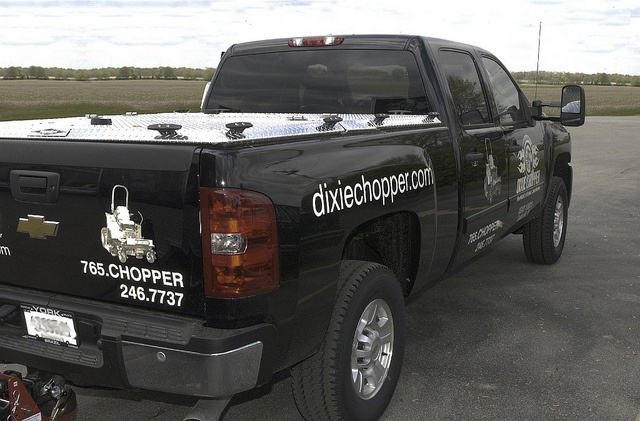Describe the objects in this image and their specific colors. I can see a truck in white, black, gray, and darkgray tones in this image. 